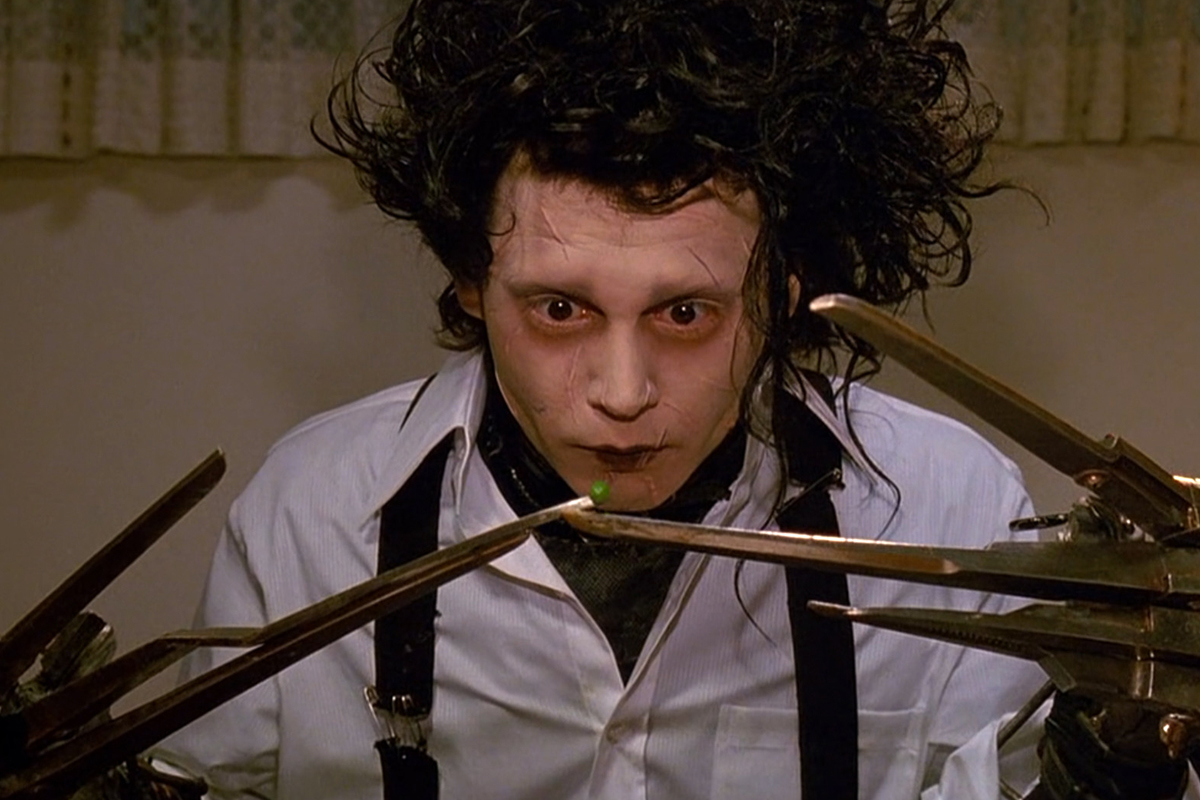How does Edward's appearance influence your perception of his character? Edward's unique appearance, particularly his scissor hands and stark facial features, immediately sets him apart as an outsider and elicits a blend of sympathy and curiosity. His pale, almost ghost-like complexion and unsettling hands suggest a creature of fantasy, caught between the human world and something otherworldly. This visage strongly influences the viewer's perception, emphasizing themes of alienation and the dichotomy between his gentle nature and fearsome appearance. 